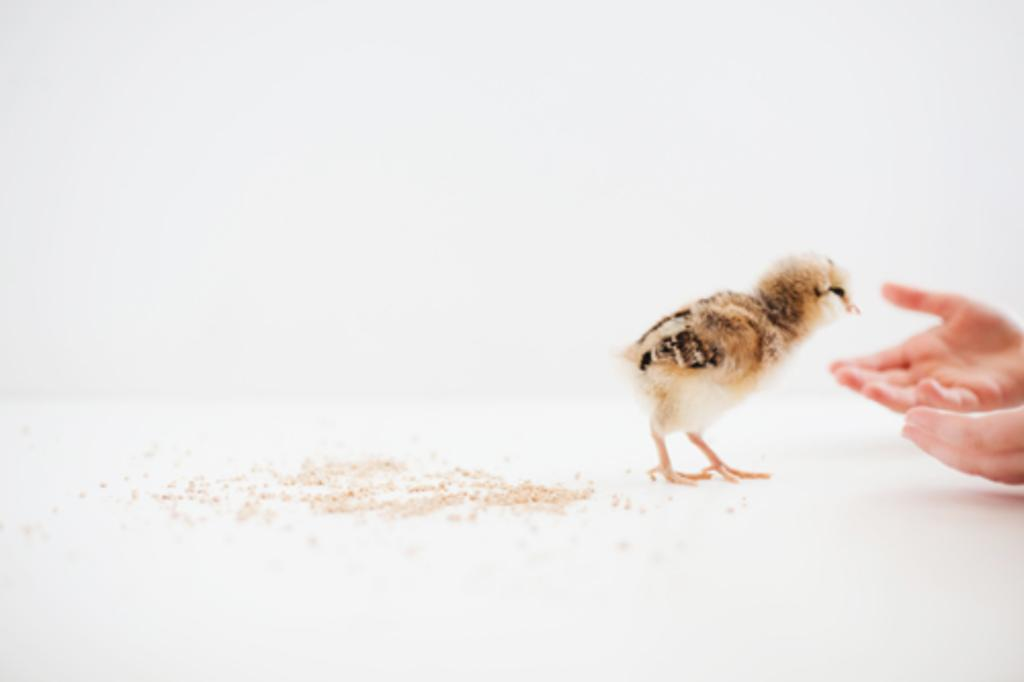What is the main subject in the middle of the image? There is a chick in the middle of the image. What color is the floor in the image? The floor in the image is white. What color is the background in the image? The background of the image is white. What belief does the chick have about the sneeze in the image? There is no sneeze present in the image, and therefore no belief can be attributed to the chick. 